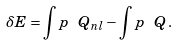Convert formula to latex. <formula><loc_0><loc_0><loc_500><loc_500>\delta E = \int p \ Q _ { n l } - \int p \ Q \, .</formula> 